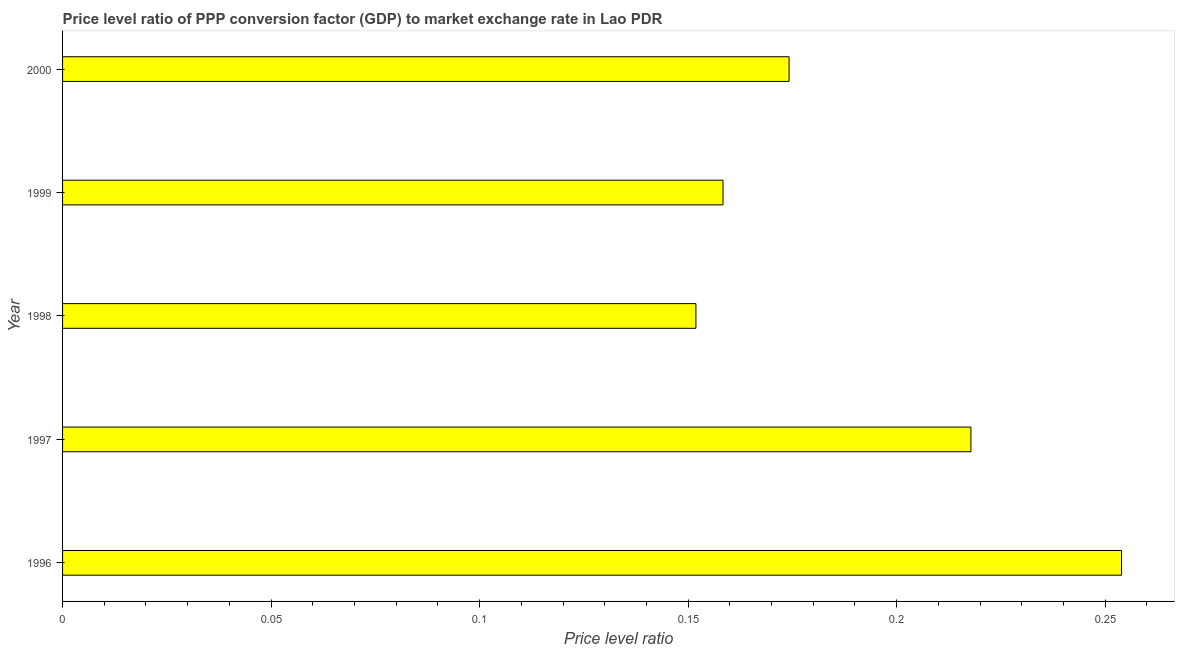What is the title of the graph?
Provide a succinct answer. Price level ratio of PPP conversion factor (GDP) to market exchange rate in Lao PDR. What is the label or title of the X-axis?
Your response must be concise. Price level ratio. What is the price level ratio in 1998?
Your answer should be very brief. 0.15. Across all years, what is the maximum price level ratio?
Make the answer very short. 0.25. Across all years, what is the minimum price level ratio?
Give a very brief answer. 0.15. In which year was the price level ratio maximum?
Offer a very short reply. 1996. What is the sum of the price level ratio?
Provide a succinct answer. 0.96. What is the difference between the price level ratio in 1997 and 2000?
Ensure brevity in your answer.  0.04. What is the average price level ratio per year?
Provide a short and direct response. 0.19. What is the median price level ratio?
Provide a succinct answer. 0.17. What is the ratio of the price level ratio in 1996 to that in 2000?
Offer a terse response. 1.46. What is the difference between the highest and the second highest price level ratio?
Ensure brevity in your answer.  0.04. Is the sum of the price level ratio in 1997 and 1999 greater than the maximum price level ratio across all years?
Your answer should be compact. Yes. In how many years, is the price level ratio greater than the average price level ratio taken over all years?
Your answer should be very brief. 2. How many bars are there?
Provide a short and direct response. 5. Are the values on the major ticks of X-axis written in scientific E-notation?
Your answer should be very brief. No. What is the Price level ratio in 1996?
Provide a short and direct response. 0.25. What is the Price level ratio in 1997?
Keep it short and to the point. 0.22. What is the Price level ratio in 1998?
Give a very brief answer. 0.15. What is the Price level ratio in 1999?
Keep it short and to the point. 0.16. What is the Price level ratio in 2000?
Keep it short and to the point. 0.17. What is the difference between the Price level ratio in 1996 and 1997?
Your answer should be compact. 0.04. What is the difference between the Price level ratio in 1996 and 1998?
Offer a terse response. 0.1. What is the difference between the Price level ratio in 1996 and 1999?
Your answer should be compact. 0.1. What is the difference between the Price level ratio in 1996 and 2000?
Offer a very short reply. 0.08. What is the difference between the Price level ratio in 1997 and 1998?
Ensure brevity in your answer.  0.07. What is the difference between the Price level ratio in 1997 and 1999?
Keep it short and to the point. 0.06. What is the difference between the Price level ratio in 1997 and 2000?
Provide a short and direct response. 0.04. What is the difference between the Price level ratio in 1998 and 1999?
Provide a succinct answer. -0.01. What is the difference between the Price level ratio in 1998 and 2000?
Provide a succinct answer. -0.02. What is the difference between the Price level ratio in 1999 and 2000?
Your response must be concise. -0.02. What is the ratio of the Price level ratio in 1996 to that in 1997?
Your response must be concise. 1.17. What is the ratio of the Price level ratio in 1996 to that in 1998?
Provide a succinct answer. 1.67. What is the ratio of the Price level ratio in 1996 to that in 1999?
Ensure brevity in your answer.  1.6. What is the ratio of the Price level ratio in 1996 to that in 2000?
Provide a succinct answer. 1.46. What is the ratio of the Price level ratio in 1997 to that in 1998?
Your answer should be compact. 1.43. What is the ratio of the Price level ratio in 1997 to that in 1999?
Provide a short and direct response. 1.38. What is the ratio of the Price level ratio in 1997 to that in 2000?
Offer a terse response. 1.25. What is the ratio of the Price level ratio in 1998 to that in 2000?
Keep it short and to the point. 0.87. What is the ratio of the Price level ratio in 1999 to that in 2000?
Your answer should be very brief. 0.91. 